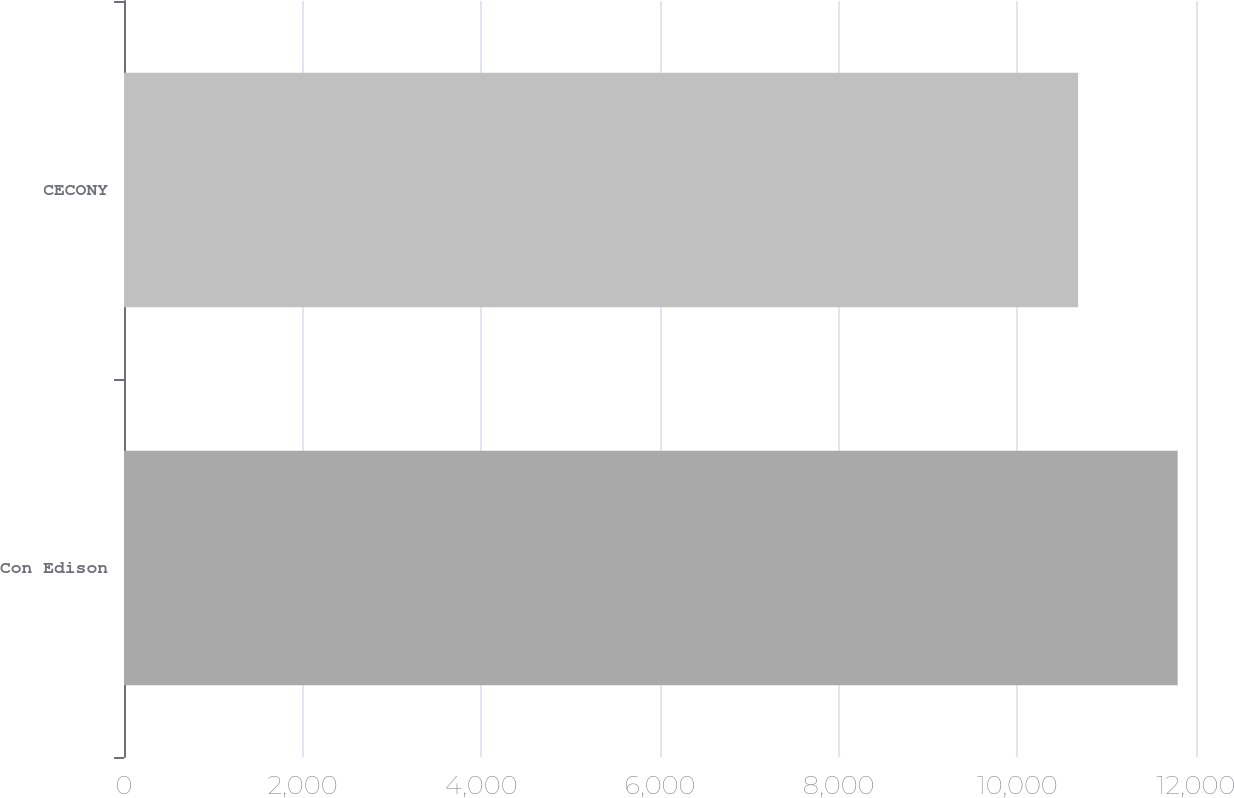Convert chart. <chart><loc_0><loc_0><loc_500><loc_500><bar_chart><fcel>Con Edison<fcel>CECONY<nl><fcel>11795<fcel>10680<nl></chart> 